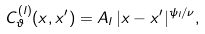<formula> <loc_0><loc_0><loc_500><loc_500>C _ { \vartheta } ^ { ( l ) } ( x , x ^ { \prime } ) = A _ { l } \, | x - x ^ { \prime } | ^ { \psi _ { l } / \nu } ,</formula> 